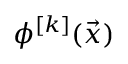<formula> <loc_0><loc_0><loc_500><loc_500>\phi ^ { [ k ] } ( \vec { x } )</formula> 